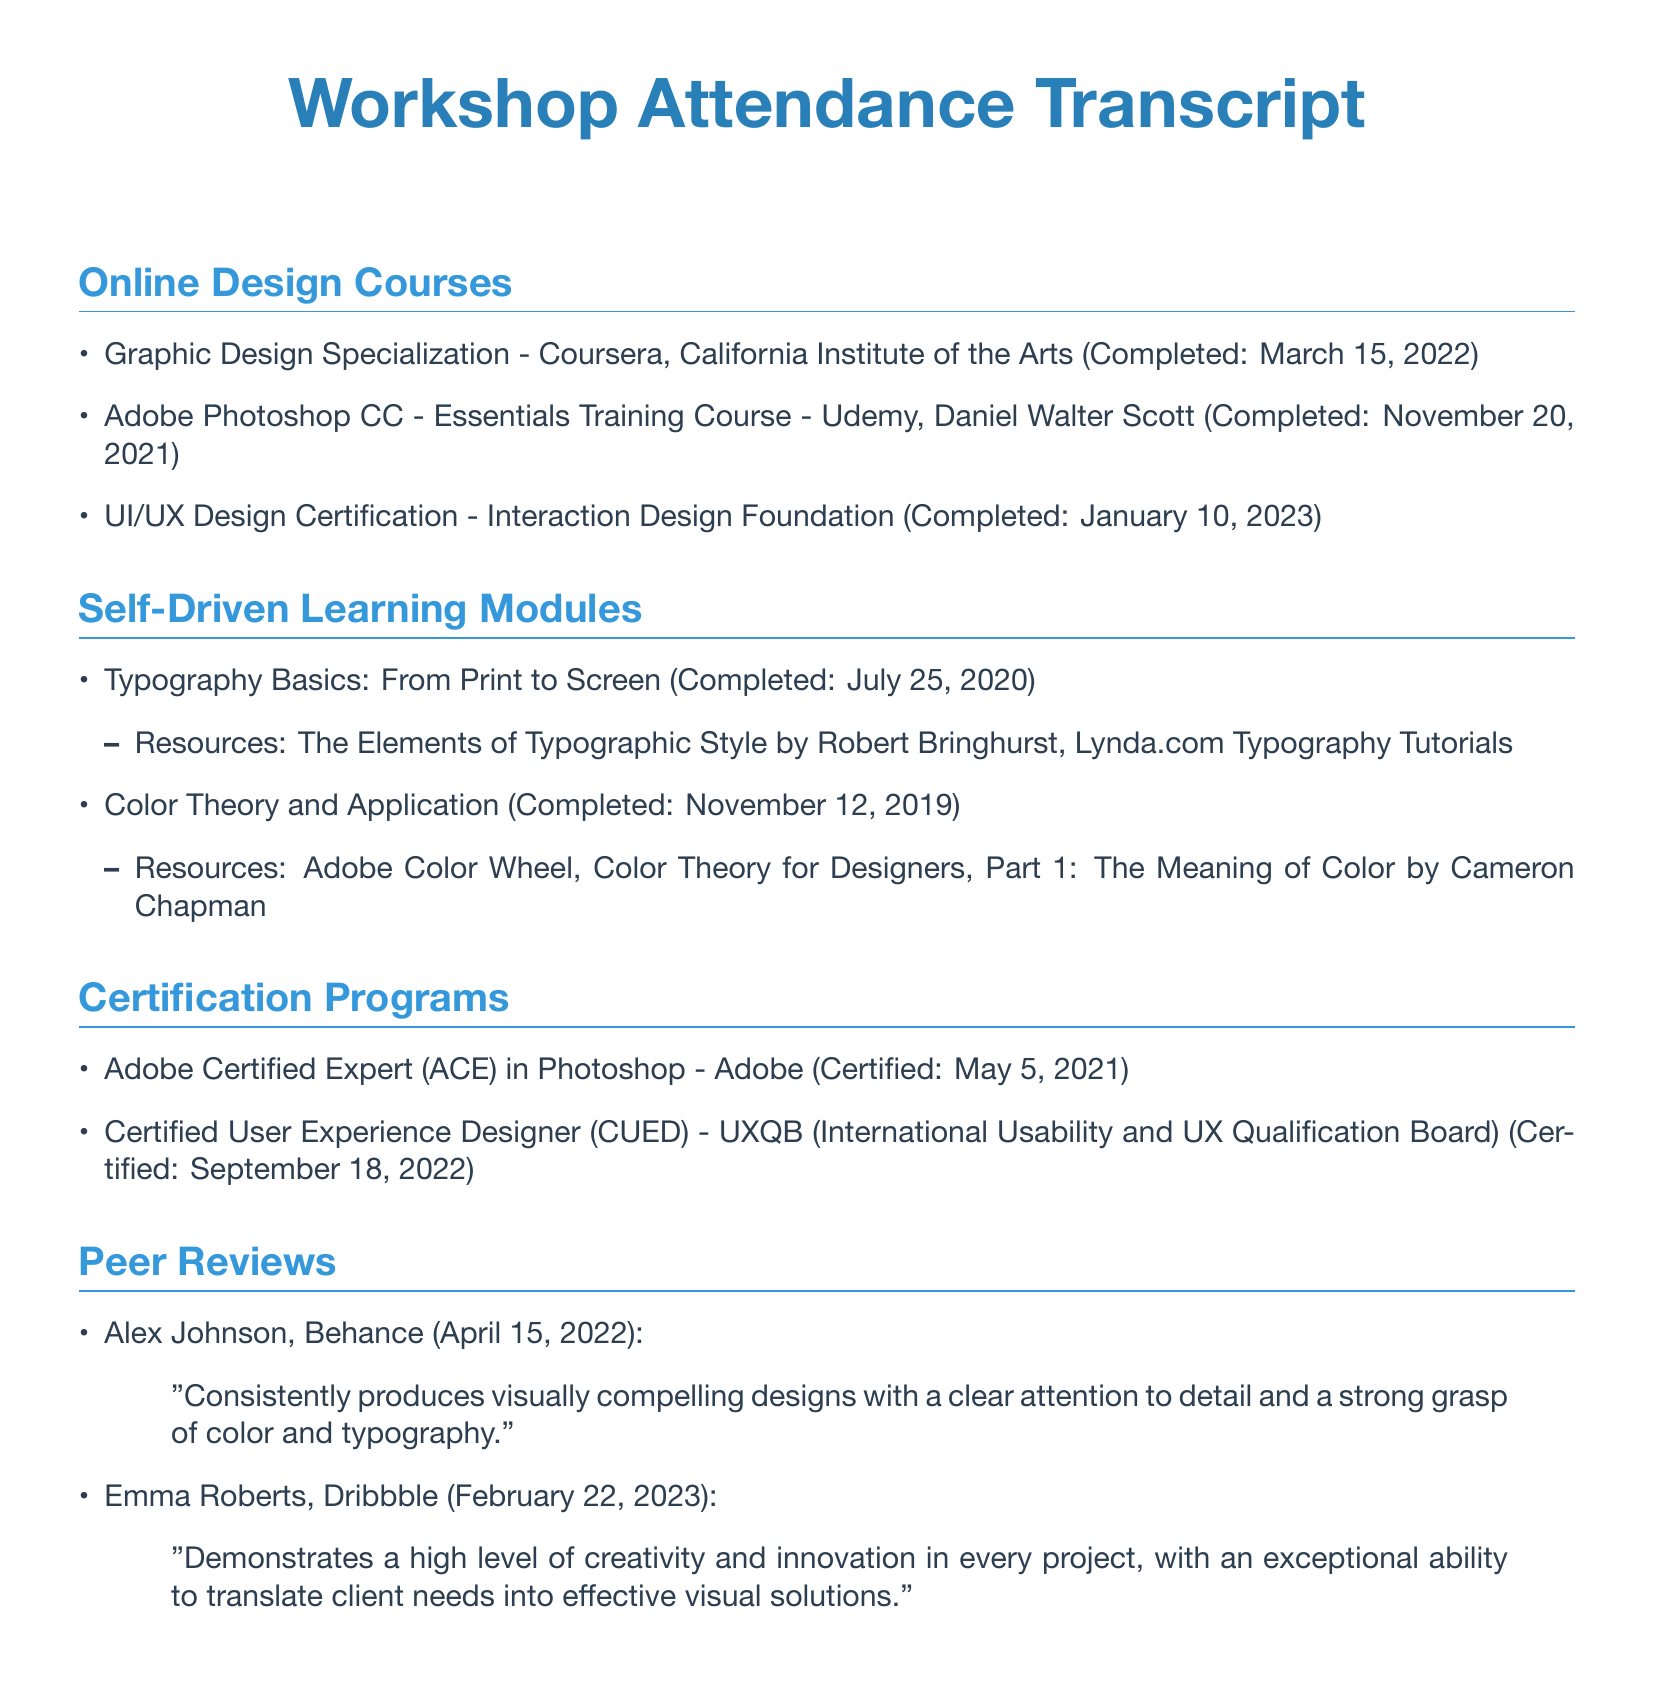What are the names of the online design courses completed? The document lists names of courses such as Graphic Design Specialization, Adobe Photoshop CC - Essentials Training Course, and UI/UX Design Certification.
Answer: Graphic Design Specialization, Adobe Photoshop CC - Essentials Training Course, UI/UX Design Certification When was the Color Theory and Application module completed? The completion date of the Color Theory and Application module is mentioned under Self-Driven Learning Modules.
Answer: November 12, 2019 How many certification programs are listed in the document? The document includes two certification programs in the Certification Programs section.
Answer: 2 Who provided a peer review on April 15, 2022? The document includes a peer review from Alex Johnson dated April 15, 2022.
Answer: Alex Johnson What is the certification title awarded on May 5, 2021? The document mentions the Adobe Certified Expert (ACE) in Photoshop as the certification obtained on that date.
Answer: Adobe Certified Expert (ACE) in Photoshop Which platform did Emma Roberts review on? The document indicates that Emma Roberts provided a review on Dribbble.
Answer: Dribbble What is the resource mentioned for Typography Basics? The document lists The Elements of Typographic Style as a resource for Typography Basics under the Self-Driven Learning Modules.
Answer: The Elements of Typographic Style Which organization certified the Certified User Experience Designer? The certification for Certified User Experience Designer is awarded by the UXQB.
Answer: UXQB 